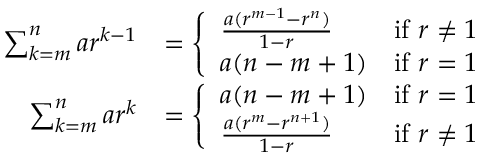Convert formula to latex. <formula><loc_0><loc_0><loc_500><loc_500>{ \begin{array} { r l } { \sum _ { k = m } ^ { n } a r ^ { k - 1 } } & { = { \left \{ \begin{array} { l l } { { \frac { a ( r ^ { m - 1 } - r ^ { n } ) } { 1 - r } } } & { { i f } r \neq 1 } \\ { a ( n - m + 1 ) } & { { i f } r = 1 } \end{array} } } \\ { \sum _ { k = m } ^ { n } a r ^ { k } } & { = { \left \{ \begin{array} { l l } { a ( n - m + 1 ) } & { { i f } r = 1 } \\ { { \frac { a ( r ^ { m } - r ^ { n + 1 } ) } { 1 - r } } } & { { i f } r \neq 1 } \end{array} } } \end{array} }</formula> 